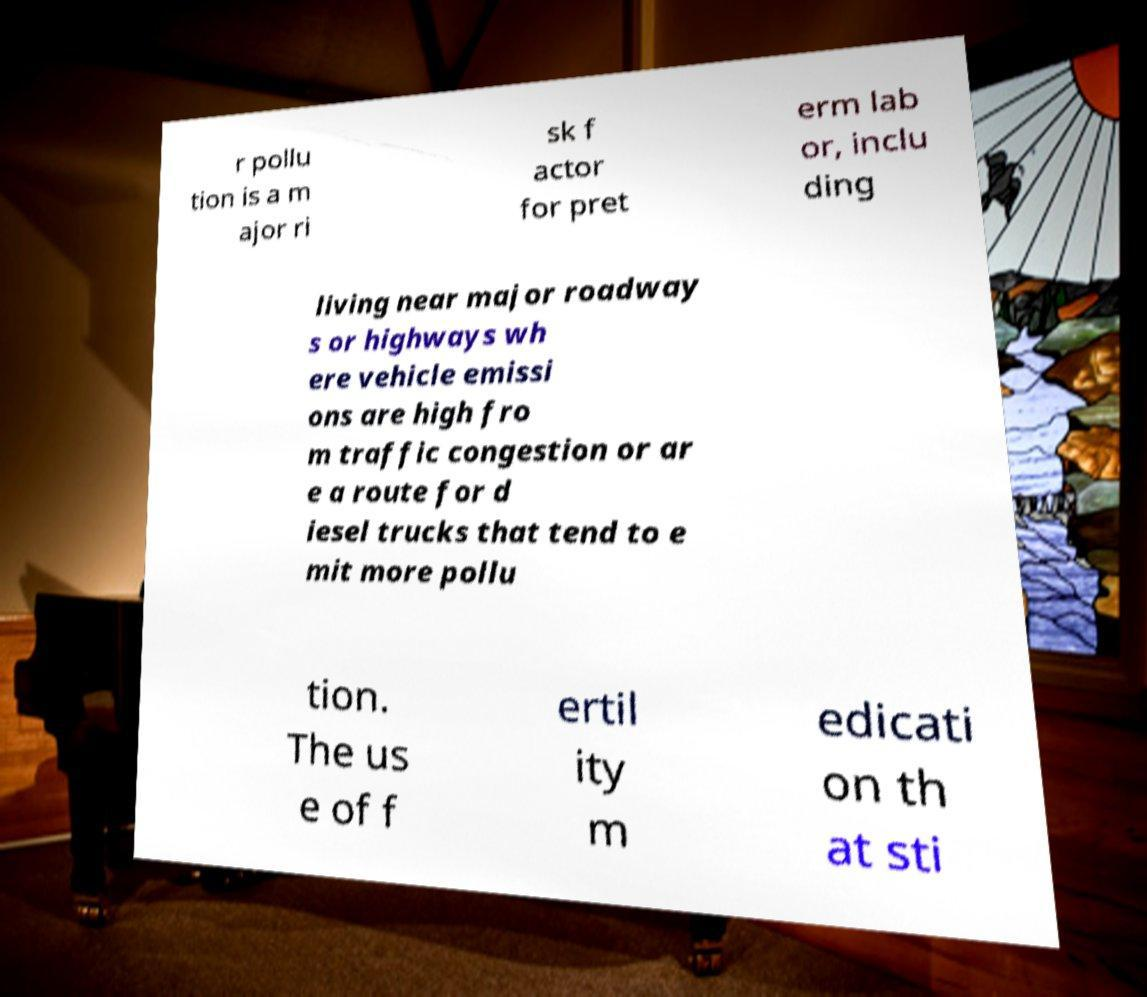I need the written content from this picture converted into text. Can you do that? r pollu tion is a m ajor ri sk f actor for pret erm lab or, inclu ding living near major roadway s or highways wh ere vehicle emissi ons are high fro m traffic congestion or ar e a route for d iesel trucks that tend to e mit more pollu tion. The us e of f ertil ity m edicati on th at sti 